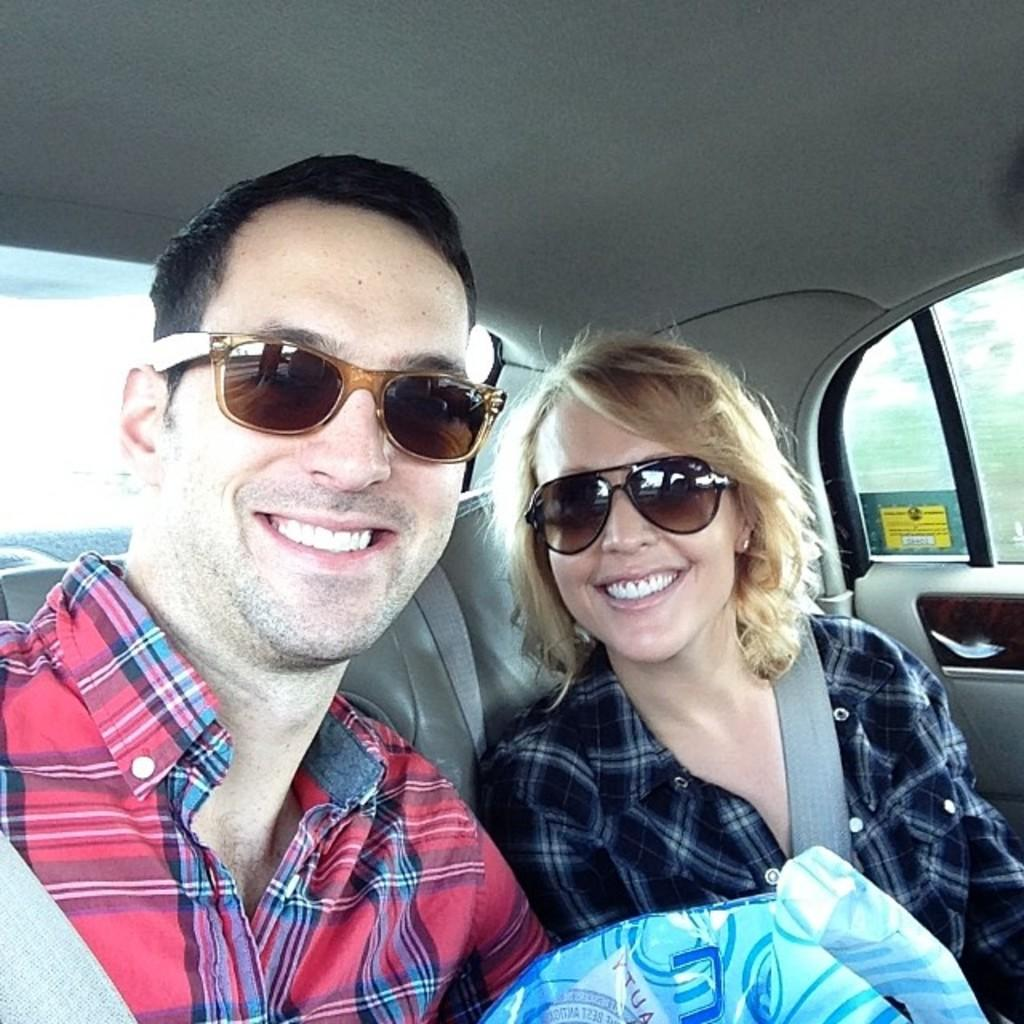How many people are in the image? There are two people in the image. Can you describe the individuals in the image? One of the people is a man, and the other person is a woman. Where are the man and woman located in the image? The man and woman are sitting in a car. What expression do the man and woman have in the image? Both the man and woman are smiling. What type of crime is being committed in the image? There is no indication of a crime being committed in the image; the man and woman are simply sitting in a car and smiling. 